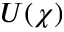<formula> <loc_0><loc_0><loc_500><loc_500>U ( \chi )</formula> 